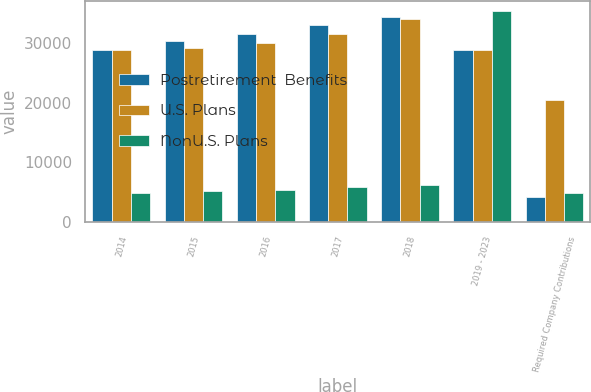Convert chart. <chart><loc_0><loc_0><loc_500><loc_500><stacked_bar_chart><ecel><fcel>2014<fcel>2015<fcel>2016<fcel>2017<fcel>2018<fcel>2019 - 2023<fcel>Required Company Contributions<nl><fcel>Postretirement  Benefits<fcel>28830<fcel>30264<fcel>31512<fcel>32993<fcel>34422<fcel>28830<fcel>4136<nl><fcel>U.S. Plans<fcel>28783<fcel>29184<fcel>30043<fcel>31559<fcel>34010<fcel>28830<fcel>20451<nl><fcel>NonU.S. Plans<fcel>4903<fcel>5162<fcel>5448<fcel>5786<fcel>6163<fcel>35326<fcel>4903<nl></chart> 